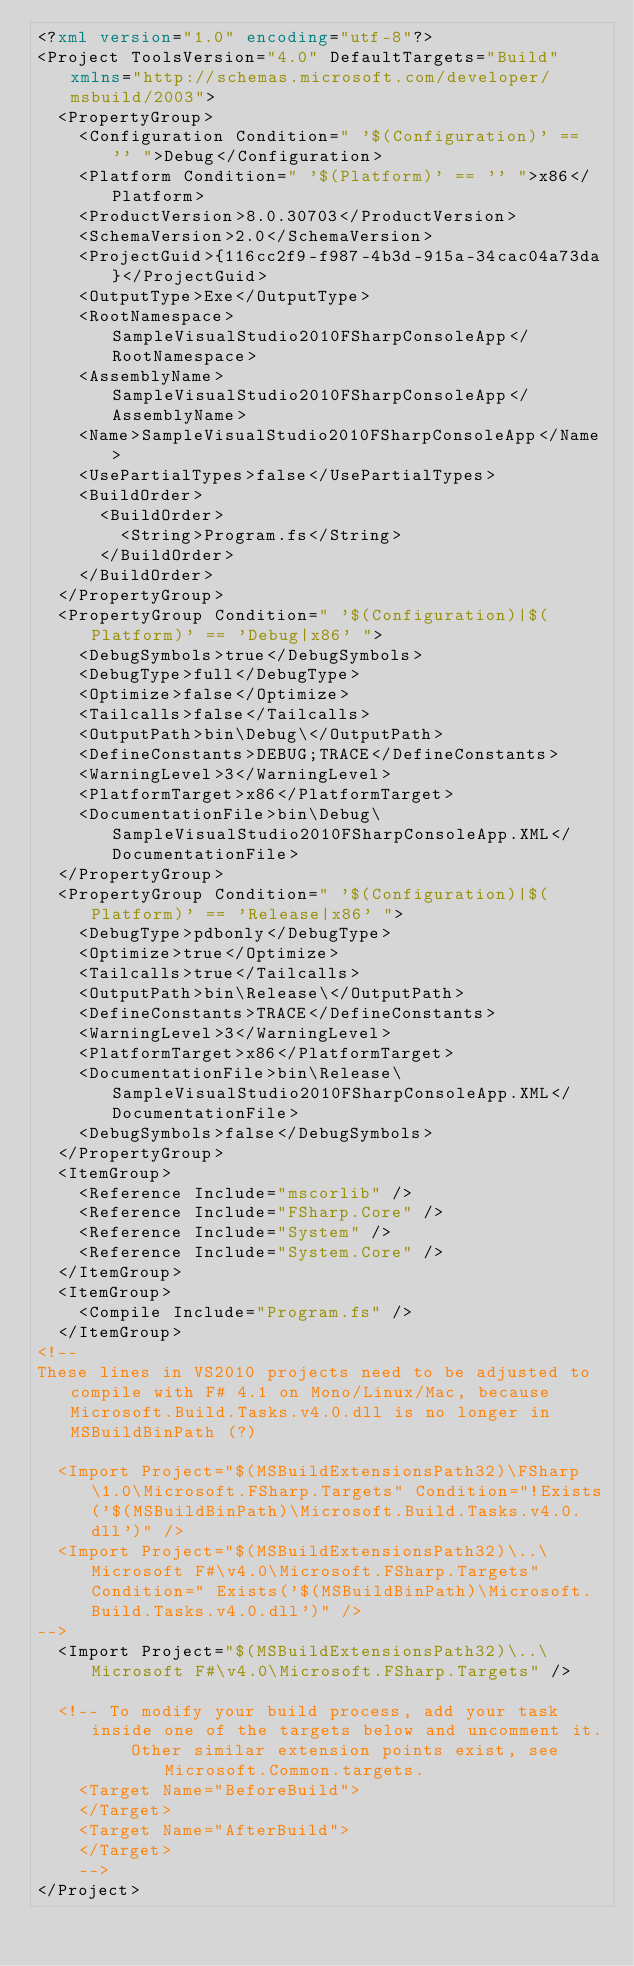Convert code to text. <code><loc_0><loc_0><loc_500><loc_500><_XML_><?xml version="1.0" encoding="utf-8"?>
<Project ToolsVersion="4.0" DefaultTargets="Build" xmlns="http://schemas.microsoft.com/developer/msbuild/2003">
  <PropertyGroup>
    <Configuration Condition=" '$(Configuration)' == '' ">Debug</Configuration>
    <Platform Condition=" '$(Platform)' == '' ">x86</Platform>
    <ProductVersion>8.0.30703</ProductVersion>
    <SchemaVersion>2.0</SchemaVersion>
    <ProjectGuid>{116cc2f9-f987-4b3d-915a-34cac04a73da}</ProjectGuid>
    <OutputType>Exe</OutputType>
    <RootNamespace>SampleVisualStudio2010FSharpConsoleApp</RootNamespace>
    <AssemblyName>SampleVisualStudio2010FSharpConsoleApp</AssemblyName>
    <Name>SampleVisualStudio2010FSharpConsoleApp</Name>
    <UsePartialTypes>false</UsePartialTypes>
    <BuildOrder>
      <BuildOrder>
        <String>Program.fs</String>
      </BuildOrder>
    </BuildOrder>
  </PropertyGroup>
  <PropertyGroup Condition=" '$(Configuration)|$(Platform)' == 'Debug|x86' ">
    <DebugSymbols>true</DebugSymbols>
    <DebugType>full</DebugType>
    <Optimize>false</Optimize>
    <Tailcalls>false</Tailcalls>
    <OutputPath>bin\Debug\</OutputPath>
    <DefineConstants>DEBUG;TRACE</DefineConstants>
    <WarningLevel>3</WarningLevel>
    <PlatformTarget>x86</PlatformTarget>
    <DocumentationFile>bin\Debug\SampleVisualStudio2010FSharpConsoleApp.XML</DocumentationFile>
  </PropertyGroup>
  <PropertyGroup Condition=" '$(Configuration)|$(Platform)' == 'Release|x86' ">
    <DebugType>pdbonly</DebugType>
    <Optimize>true</Optimize>
    <Tailcalls>true</Tailcalls>
    <OutputPath>bin\Release\</OutputPath>
    <DefineConstants>TRACE</DefineConstants>
    <WarningLevel>3</WarningLevel>
    <PlatformTarget>x86</PlatformTarget>
    <DocumentationFile>bin\Release\SampleVisualStudio2010FSharpConsoleApp.XML</DocumentationFile>
    <DebugSymbols>false</DebugSymbols>
  </PropertyGroup>
  <ItemGroup>
    <Reference Include="mscorlib" />
    <Reference Include="FSharp.Core" />
    <Reference Include="System" />
    <Reference Include="System.Core" />
  </ItemGroup>
  <ItemGroup>
    <Compile Include="Program.fs" />
  </ItemGroup>
<!--
These lines in VS2010 projects need to be adjusted to compile with F# 4.1 on Mono/Linux/Mac, because Microsoft.Build.Tasks.v4.0.dll is no longer in MSBuildBinPath (?)

  <Import Project="$(MSBuildExtensionsPath32)\FSharp\1.0\Microsoft.FSharp.Targets" Condition="!Exists('$(MSBuildBinPath)\Microsoft.Build.Tasks.v4.0.dll')" />
  <Import Project="$(MSBuildExtensionsPath32)\..\Microsoft F#\v4.0\Microsoft.FSharp.Targets" Condition=" Exists('$(MSBuildBinPath)\Microsoft.Build.Tasks.v4.0.dll')" />
-->
  <Import Project="$(MSBuildExtensionsPath32)\..\Microsoft F#\v4.0\Microsoft.FSharp.Targets" />

  <!-- To modify your build process, add your task inside one of the targets below and uncomment it. 
	     Other similar extension points exist, see Microsoft.Common.targets.
	<Target Name="BeforeBuild">
	</Target>
	<Target Name="AfterBuild">
	</Target>
	-->
</Project></code> 